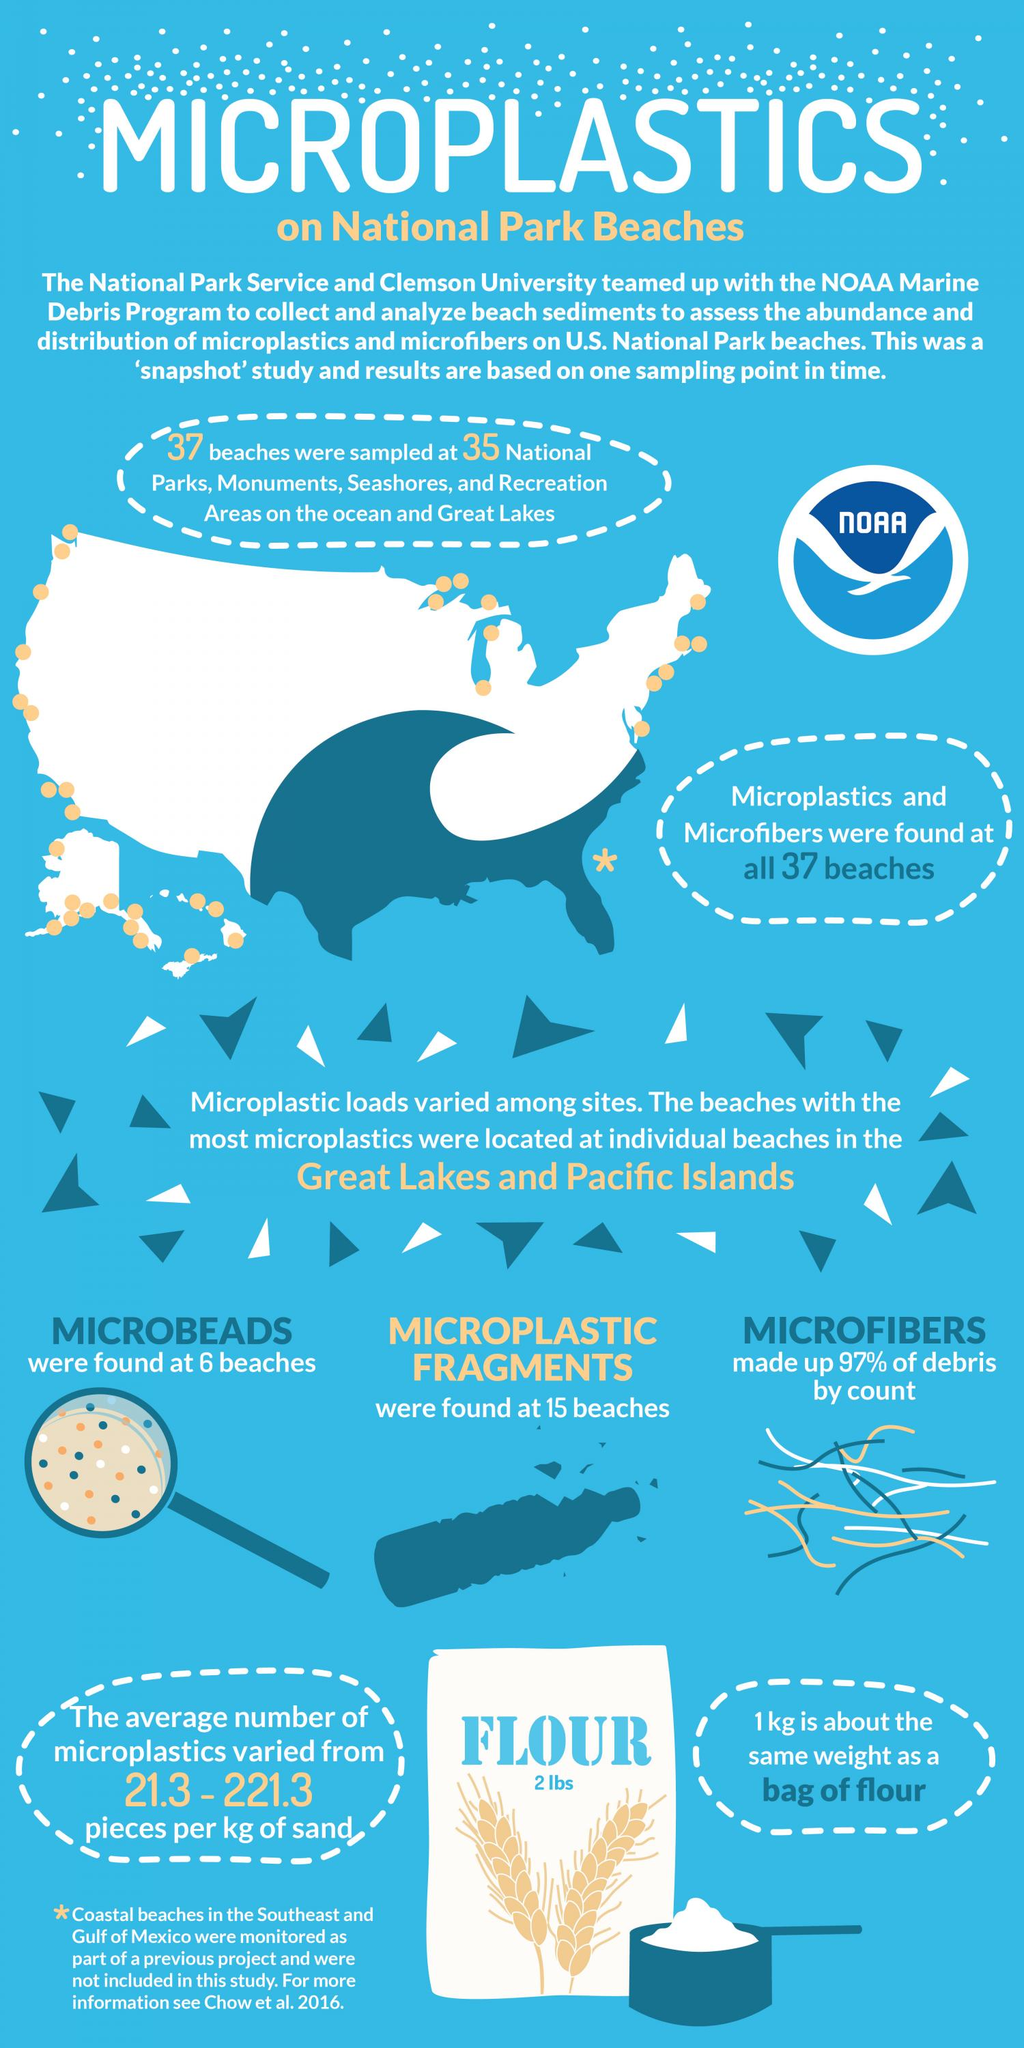Specify some key components in this picture. The geometric shape used in the map to indicate the beaches included in the study is a circle. Microplastic fragments were discovered at 15 beaches. The study found microbeads at six locations. Ninety-seven percent of debris collected consisted of microfibers. 